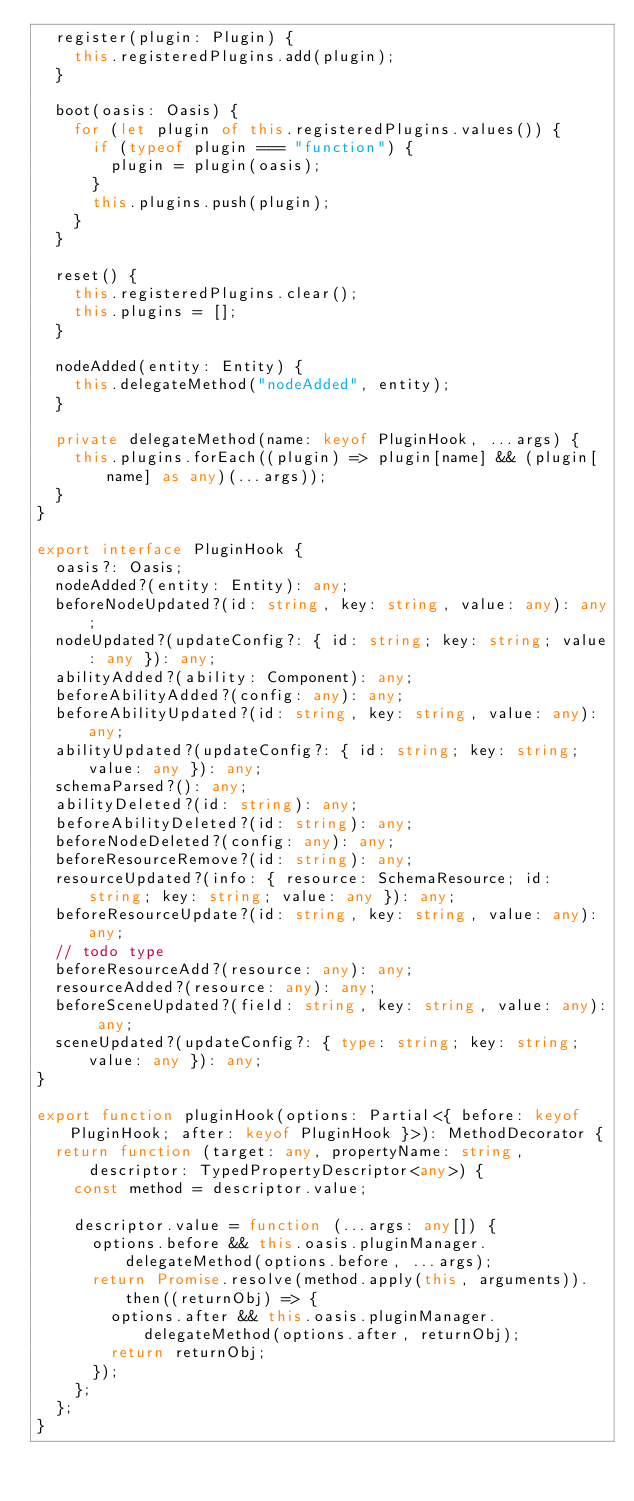<code> <loc_0><loc_0><loc_500><loc_500><_TypeScript_>  register(plugin: Plugin) {
    this.registeredPlugins.add(plugin);
  }

  boot(oasis: Oasis) {
    for (let plugin of this.registeredPlugins.values()) {
      if (typeof plugin === "function") {
        plugin = plugin(oasis);
      }
      this.plugins.push(plugin);
    }
  }

  reset() {
    this.registeredPlugins.clear();
    this.plugins = [];
  }

  nodeAdded(entity: Entity) {
    this.delegateMethod("nodeAdded", entity);
  }

  private delegateMethod(name: keyof PluginHook, ...args) {
    this.plugins.forEach((plugin) => plugin[name] && (plugin[name] as any)(...args));
  }
}

export interface PluginHook {
  oasis?: Oasis;
  nodeAdded?(entity: Entity): any;
  beforeNodeUpdated?(id: string, key: string, value: any): any;
  nodeUpdated?(updateConfig?: { id: string; key: string; value: any }): any;
  abilityAdded?(ability: Component): any;
  beforeAbilityAdded?(config: any): any;
  beforeAbilityUpdated?(id: string, key: string, value: any): any;
  abilityUpdated?(updateConfig?: { id: string; key: string; value: any }): any;
  schemaParsed?(): any;
  abilityDeleted?(id: string): any;
  beforeAbilityDeleted?(id: string): any;
  beforeNodeDeleted?(config: any): any;
  beforeResourceRemove?(id: string): any;
  resourceUpdated?(info: { resource: SchemaResource; id: string; key: string; value: any }): any;
  beforeResourceUpdate?(id: string, key: string, value: any): any;
  // todo type
  beforeResourceAdd?(resource: any): any;
  resourceAdded?(resource: any): any;
  beforeSceneUpdated?(field: string, key: string, value: any): any;
  sceneUpdated?(updateConfig?: { type: string; key: string; value: any }): any;
}

export function pluginHook(options: Partial<{ before: keyof PluginHook; after: keyof PluginHook }>): MethodDecorator {
  return function (target: any, propertyName: string, descriptor: TypedPropertyDescriptor<any>) {
    const method = descriptor.value;

    descriptor.value = function (...args: any[]) {
      options.before && this.oasis.pluginManager.delegateMethod(options.before, ...args);
      return Promise.resolve(method.apply(this, arguments)).then((returnObj) => {
        options.after && this.oasis.pluginManager.delegateMethod(options.after, returnObj);
        return returnObj;
      });
    };
  };
}
</code> 